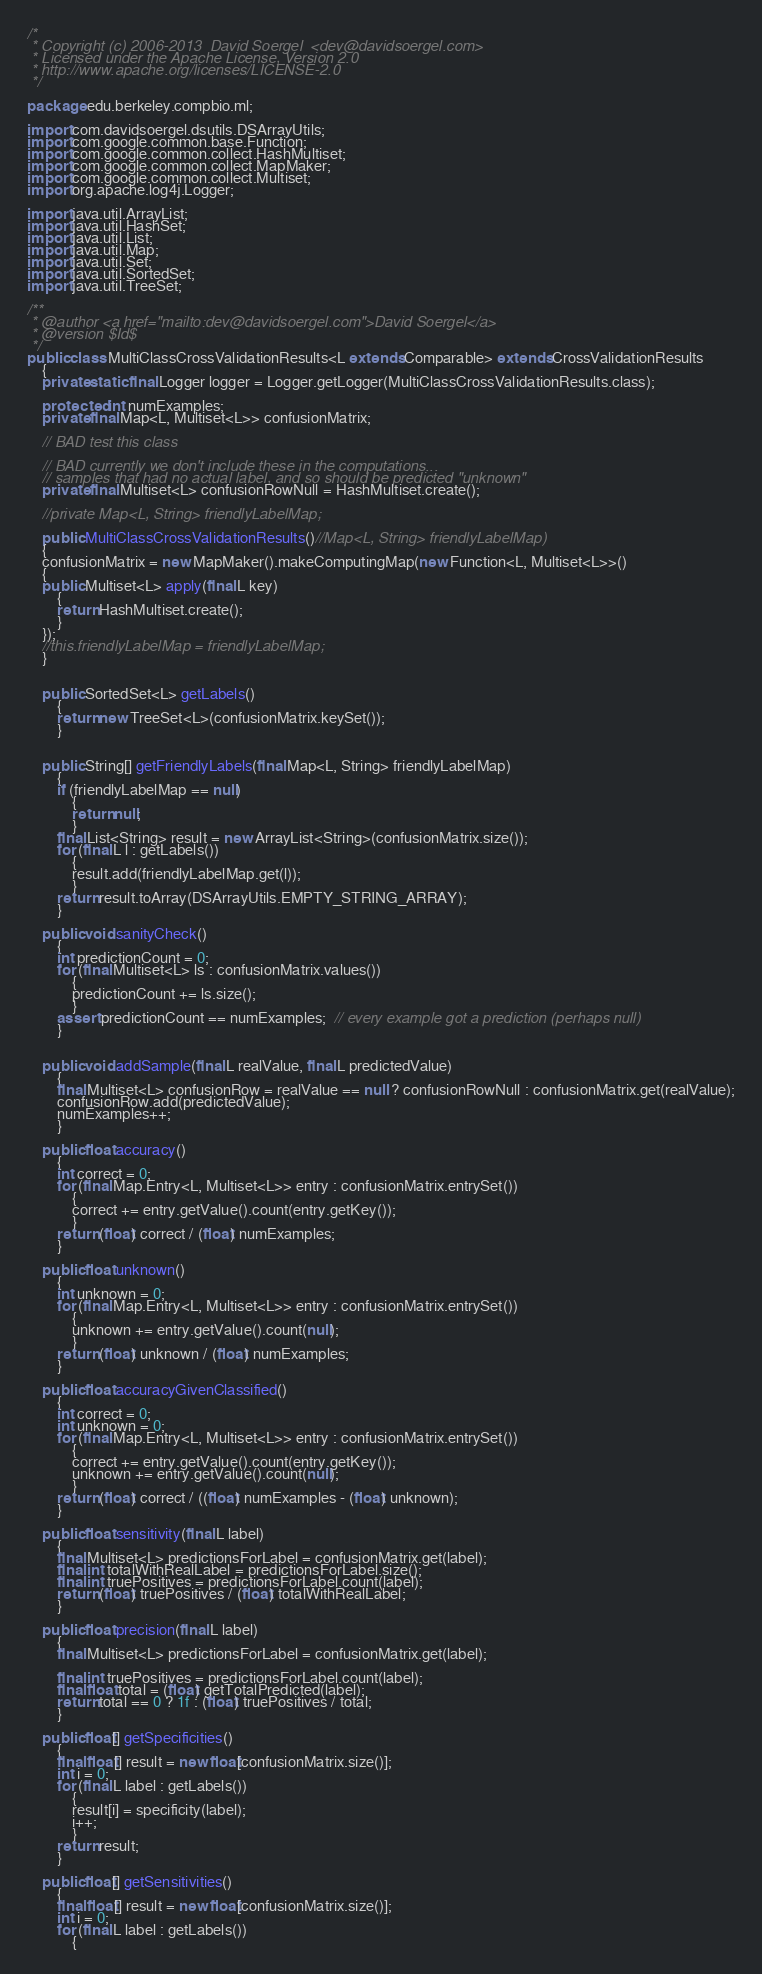<code> <loc_0><loc_0><loc_500><loc_500><_Java_>/*
 * Copyright (c) 2006-2013  David Soergel  <dev@davidsoergel.com>
 * Licensed under the Apache License, Version 2.0
 * http://www.apache.org/licenses/LICENSE-2.0
 */

package edu.berkeley.compbio.ml;

import com.davidsoergel.dsutils.DSArrayUtils;
import com.google.common.base.Function;
import com.google.common.collect.HashMultiset;
import com.google.common.collect.MapMaker;
import com.google.common.collect.Multiset;
import org.apache.log4j.Logger;

import java.util.ArrayList;
import java.util.HashSet;
import java.util.List;
import java.util.Map;
import java.util.Set;
import java.util.SortedSet;
import java.util.TreeSet;

/**
 * @author <a href="mailto:dev@davidsoergel.com">David Soergel</a>
 * @version $Id$
 */
public class MultiClassCrossValidationResults<L extends Comparable> extends CrossValidationResults
	{
	private static final Logger logger = Logger.getLogger(MultiClassCrossValidationResults.class);

	protected int numExamples;
	private final Map<L, Multiset<L>> confusionMatrix;

	// BAD test this class

	// BAD currently we don't include these in the computations...
	// samples that had no actual label, and so should be predicted "unknown"
	private final Multiset<L> confusionRowNull = HashMultiset.create();

	//private Map<L, String> friendlyLabelMap;

	public MultiClassCrossValidationResults()//Map<L, String> friendlyLabelMap)
	{
	confusionMatrix = new MapMaker().makeComputingMap(new Function<L, Multiset<L>>()
	{
	public Multiset<L> apply(final L key)
		{
		return HashMultiset.create();
		}
	});
	//this.friendlyLabelMap = friendlyLabelMap;
	}


	public SortedSet<L> getLabels()
		{
		return new TreeSet<L>(confusionMatrix.keySet());
		}


	public String[] getFriendlyLabels(final Map<L, String> friendlyLabelMap)
		{
		if (friendlyLabelMap == null)
			{
			return null;
			}
		final List<String> result = new ArrayList<String>(confusionMatrix.size());
		for (final L l : getLabels())
			{
			result.add(friendlyLabelMap.get(l));
			}
		return result.toArray(DSArrayUtils.EMPTY_STRING_ARRAY);
		}

	public void sanityCheck()
		{
		int predictionCount = 0;
		for (final Multiset<L> ls : confusionMatrix.values())
			{
			predictionCount += ls.size();
			}
		assert predictionCount == numExamples;  // every example got a prediction (perhaps null)
		}


	public void addSample(final L realValue, final L predictedValue)
		{
		final Multiset<L> confusionRow = realValue == null ? confusionRowNull : confusionMatrix.get(realValue);
		confusionRow.add(predictedValue);
		numExamples++;
		}

	public float accuracy()
		{
		int correct = 0;
		for (final Map.Entry<L, Multiset<L>> entry : confusionMatrix.entrySet())
			{
			correct += entry.getValue().count(entry.getKey());
			}
		return (float) correct / (float) numExamples;
		}

	public float unknown()
		{
		int unknown = 0;
		for (final Map.Entry<L, Multiset<L>> entry : confusionMatrix.entrySet())
			{
			unknown += entry.getValue().count(null);
			}
		return (float) unknown / (float) numExamples;
		}

	public float accuracyGivenClassified()
		{
		int correct = 0;
		int unknown = 0;
		for (final Map.Entry<L, Multiset<L>> entry : confusionMatrix.entrySet())
			{
			correct += entry.getValue().count(entry.getKey());
			unknown += entry.getValue().count(null);
			}
		return (float) correct / ((float) numExamples - (float) unknown);
		}

	public float sensitivity(final L label)
		{
		final Multiset<L> predictionsForLabel = confusionMatrix.get(label);
		final int totalWithRealLabel = predictionsForLabel.size();
		final int truePositives = predictionsForLabel.count(label);
		return (float) truePositives / (float) totalWithRealLabel;
		}

	public float precision(final L label)
		{
		final Multiset<L> predictionsForLabel = confusionMatrix.get(label);

		final int truePositives = predictionsForLabel.count(label);
		final float total = (float) getTotalPredicted(label);
		return total == 0 ? 1f : (float) truePositives / total;
		}

	public float[] getSpecificities()
		{
		final float[] result = new float[confusionMatrix.size()];
		int i = 0;
		for (final L label : getLabels())
			{
			result[i] = specificity(label);
			i++;
			}
		return result;
		}

	public float[] getSensitivities()
		{
		final float[] result = new float[confusionMatrix.size()];
		int i = 0;
		for (final L label : getLabels())
			{</code> 